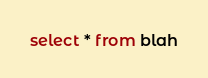Convert code to text. <code><loc_0><loc_0><loc_500><loc_500><_SQL_>select * from blah</code> 